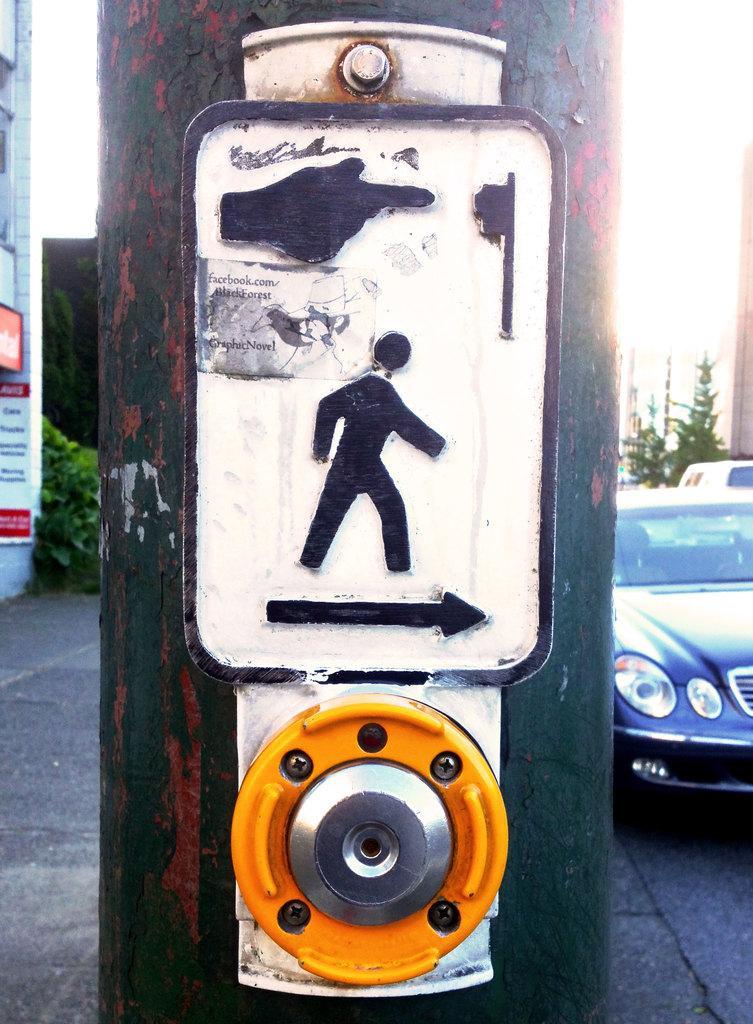Could you give a brief overview of what you see in this image? In the center of the image there is a pole and on the pole there is a direction mark. In the background we can see shrubs and trees. There is also a car on the road. 